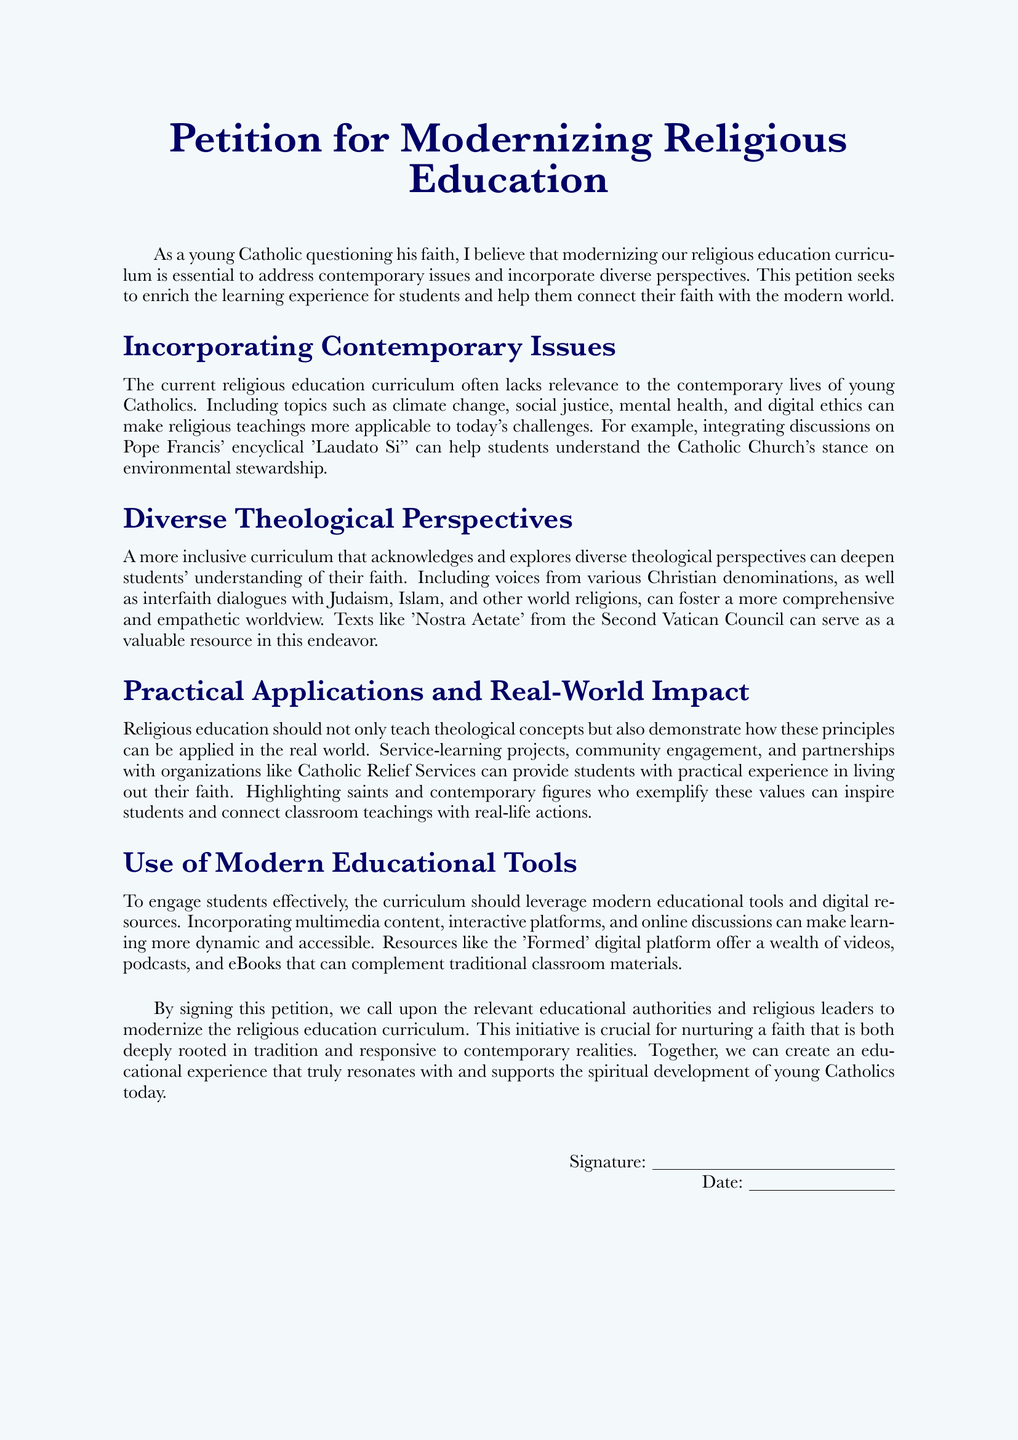what is the title of the petition? The title of the petition is prominently displayed at the beginning of the document.
Answer: Petition for Modernizing Religious Education who is the intended audience of the petition? The petition addresses educational authorities and religious leaders regarding curriculum changes.
Answer: educational authorities and religious leaders which encyclical is mentioned in the document? The encyclical referenced is discussed in the context of environmental stewardship.
Answer: Laudato Si' what is one contemporary issue suggested for inclusion in the curriculum? The petition highlights various contemporary issues, and one is specified as an example.
Answer: climate change which document from the Second Vatican Council is referenced? This document is important in discussing diverse theological perspectives.
Answer: Nostra Aetate how can practical applications be demonstrated according to the petition? The petition suggests that certain activities can illustrate how faith is lived out in the community.
Answer: service-learning projects what educational platform is mentioned for modern resources? The platform is intended to be a supplement to traditional religious education materials.
Answer: Formed what is the primary goal of this petition? The goal is outlined in the context of enriching the educational experience of young Catholics.
Answer: modernizing the religious education curriculum 